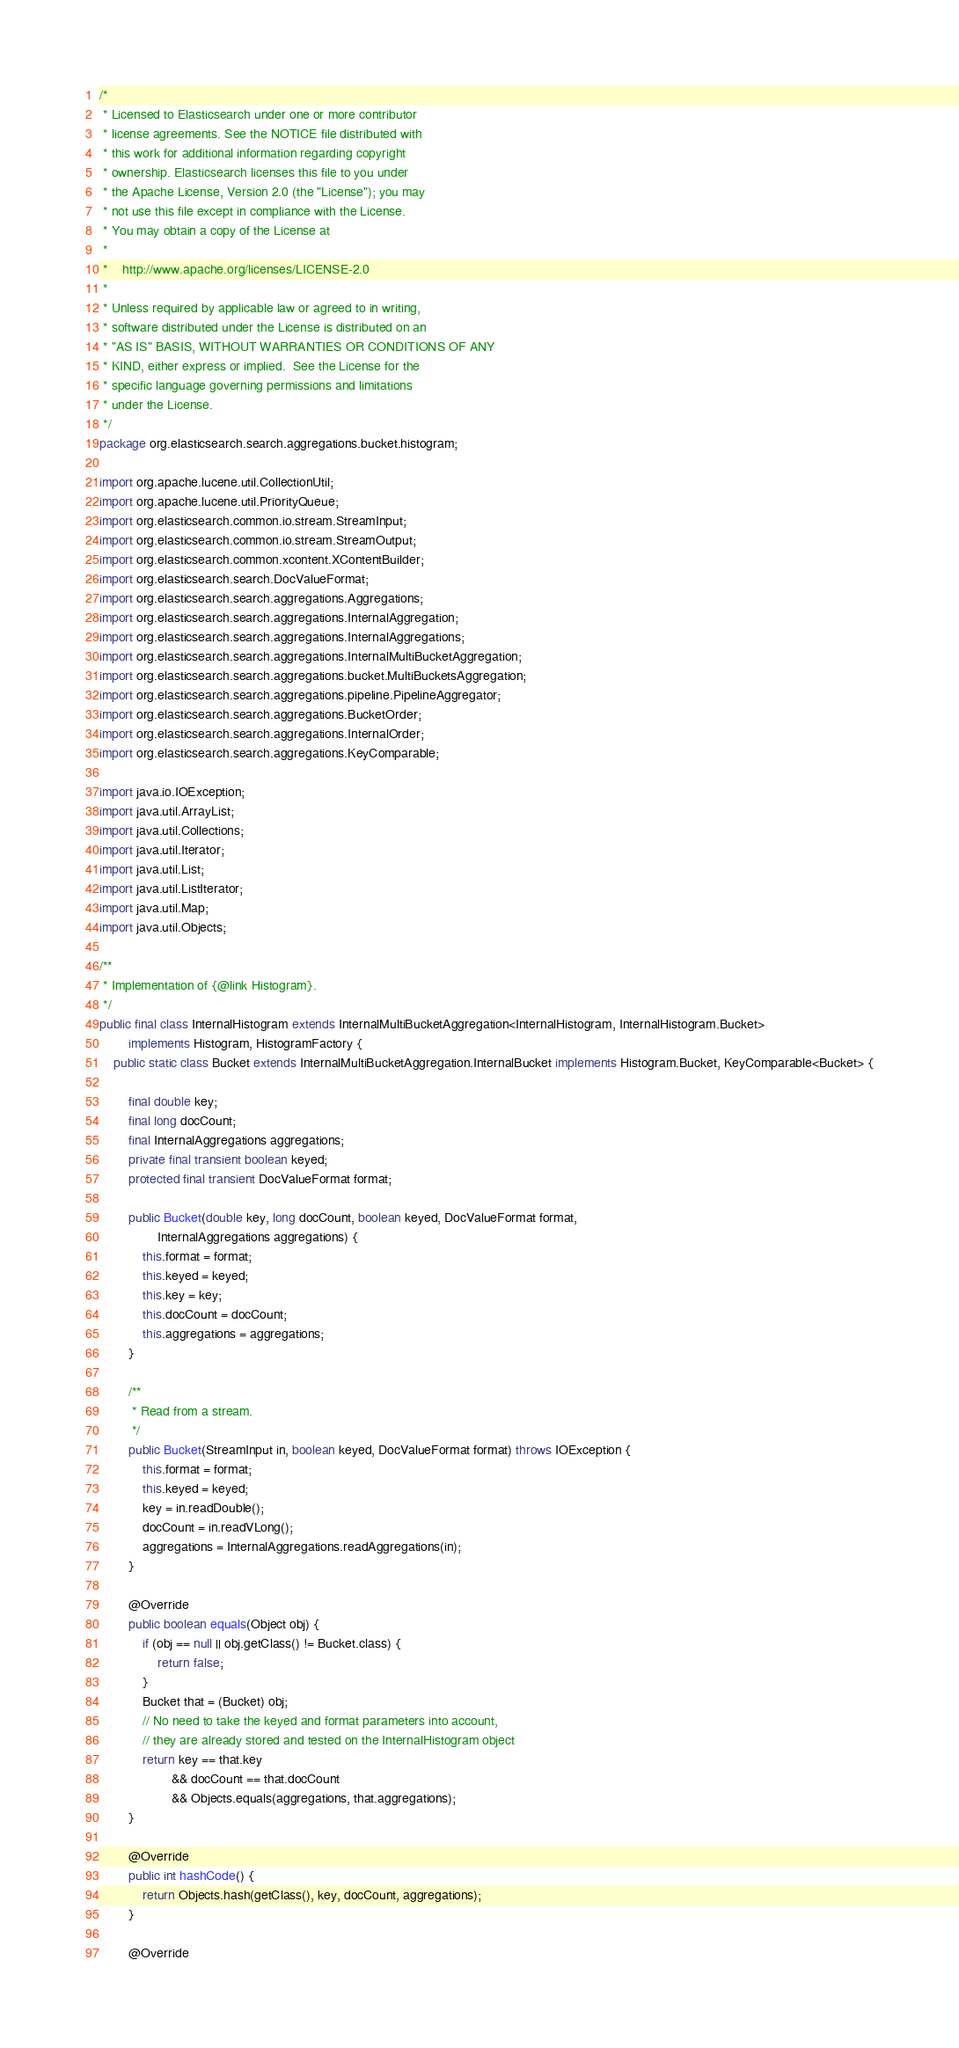Convert code to text. <code><loc_0><loc_0><loc_500><loc_500><_Java_>/*
 * Licensed to Elasticsearch under one or more contributor
 * license agreements. See the NOTICE file distributed with
 * this work for additional information regarding copyright
 * ownership. Elasticsearch licenses this file to you under
 * the Apache License, Version 2.0 (the "License"); you may
 * not use this file except in compliance with the License.
 * You may obtain a copy of the License at
 *
 *    http://www.apache.org/licenses/LICENSE-2.0
 *
 * Unless required by applicable law or agreed to in writing,
 * software distributed under the License is distributed on an
 * "AS IS" BASIS, WITHOUT WARRANTIES OR CONDITIONS OF ANY
 * KIND, either express or implied.  See the License for the
 * specific language governing permissions and limitations
 * under the License.
 */
package org.elasticsearch.search.aggregations.bucket.histogram;

import org.apache.lucene.util.CollectionUtil;
import org.apache.lucene.util.PriorityQueue;
import org.elasticsearch.common.io.stream.StreamInput;
import org.elasticsearch.common.io.stream.StreamOutput;
import org.elasticsearch.common.xcontent.XContentBuilder;
import org.elasticsearch.search.DocValueFormat;
import org.elasticsearch.search.aggregations.Aggregations;
import org.elasticsearch.search.aggregations.InternalAggregation;
import org.elasticsearch.search.aggregations.InternalAggregations;
import org.elasticsearch.search.aggregations.InternalMultiBucketAggregation;
import org.elasticsearch.search.aggregations.bucket.MultiBucketsAggregation;
import org.elasticsearch.search.aggregations.pipeline.PipelineAggregator;
import org.elasticsearch.search.aggregations.BucketOrder;
import org.elasticsearch.search.aggregations.InternalOrder;
import org.elasticsearch.search.aggregations.KeyComparable;

import java.io.IOException;
import java.util.ArrayList;
import java.util.Collections;
import java.util.Iterator;
import java.util.List;
import java.util.ListIterator;
import java.util.Map;
import java.util.Objects;

/**
 * Implementation of {@link Histogram}.
 */
public final class InternalHistogram extends InternalMultiBucketAggregation<InternalHistogram, InternalHistogram.Bucket>
        implements Histogram, HistogramFactory {
    public static class Bucket extends InternalMultiBucketAggregation.InternalBucket implements Histogram.Bucket, KeyComparable<Bucket> {

        final double key;
        final long docCount;
        final InternalAggregations aggregations;
        private final transient boolean keyed;
        protected final transient DocValueFormat format;

        public Bucket(double key, long docCount, boolean keyed, DocValueFormat format,
                InternalAggregations aggregations) {
            this.format = format;
            this.keyed = keyed;
            this.key = key;
            this.docCount = docCount;
            this.aggregations = aggregations;
        }

        /**
         * Read from a stream.
         */
        public Bucket(StreamInput in, boolean keyed, DocValueFormat format) throws IOException {
            this.format = format;
            this.keyed = keyed;
            key = in.readDouble();
            docCount = in.readVLong();
            aggregations = InternalAggregations.readAggregations(in);
        }

        @Override
        public boolean equals(Object obj) {
            if (obj == null || obj.getClass() != Bucket.class) {
                return false;
            }
            Bucket that = (Bucket) obj;
            // No need to take the keyed and format parameters into account,
            // they are already stored and tested on the InternalHistogram object
            return key == that.key
                    && docCount == that.docCount
                    && Objects.equals(aggregations, that.aggregations);
        }

        @Override
        public int hashCode() {
            return Objects.hash(getClass(), key, docCount, aggregations);
        }

        @Override</code> 